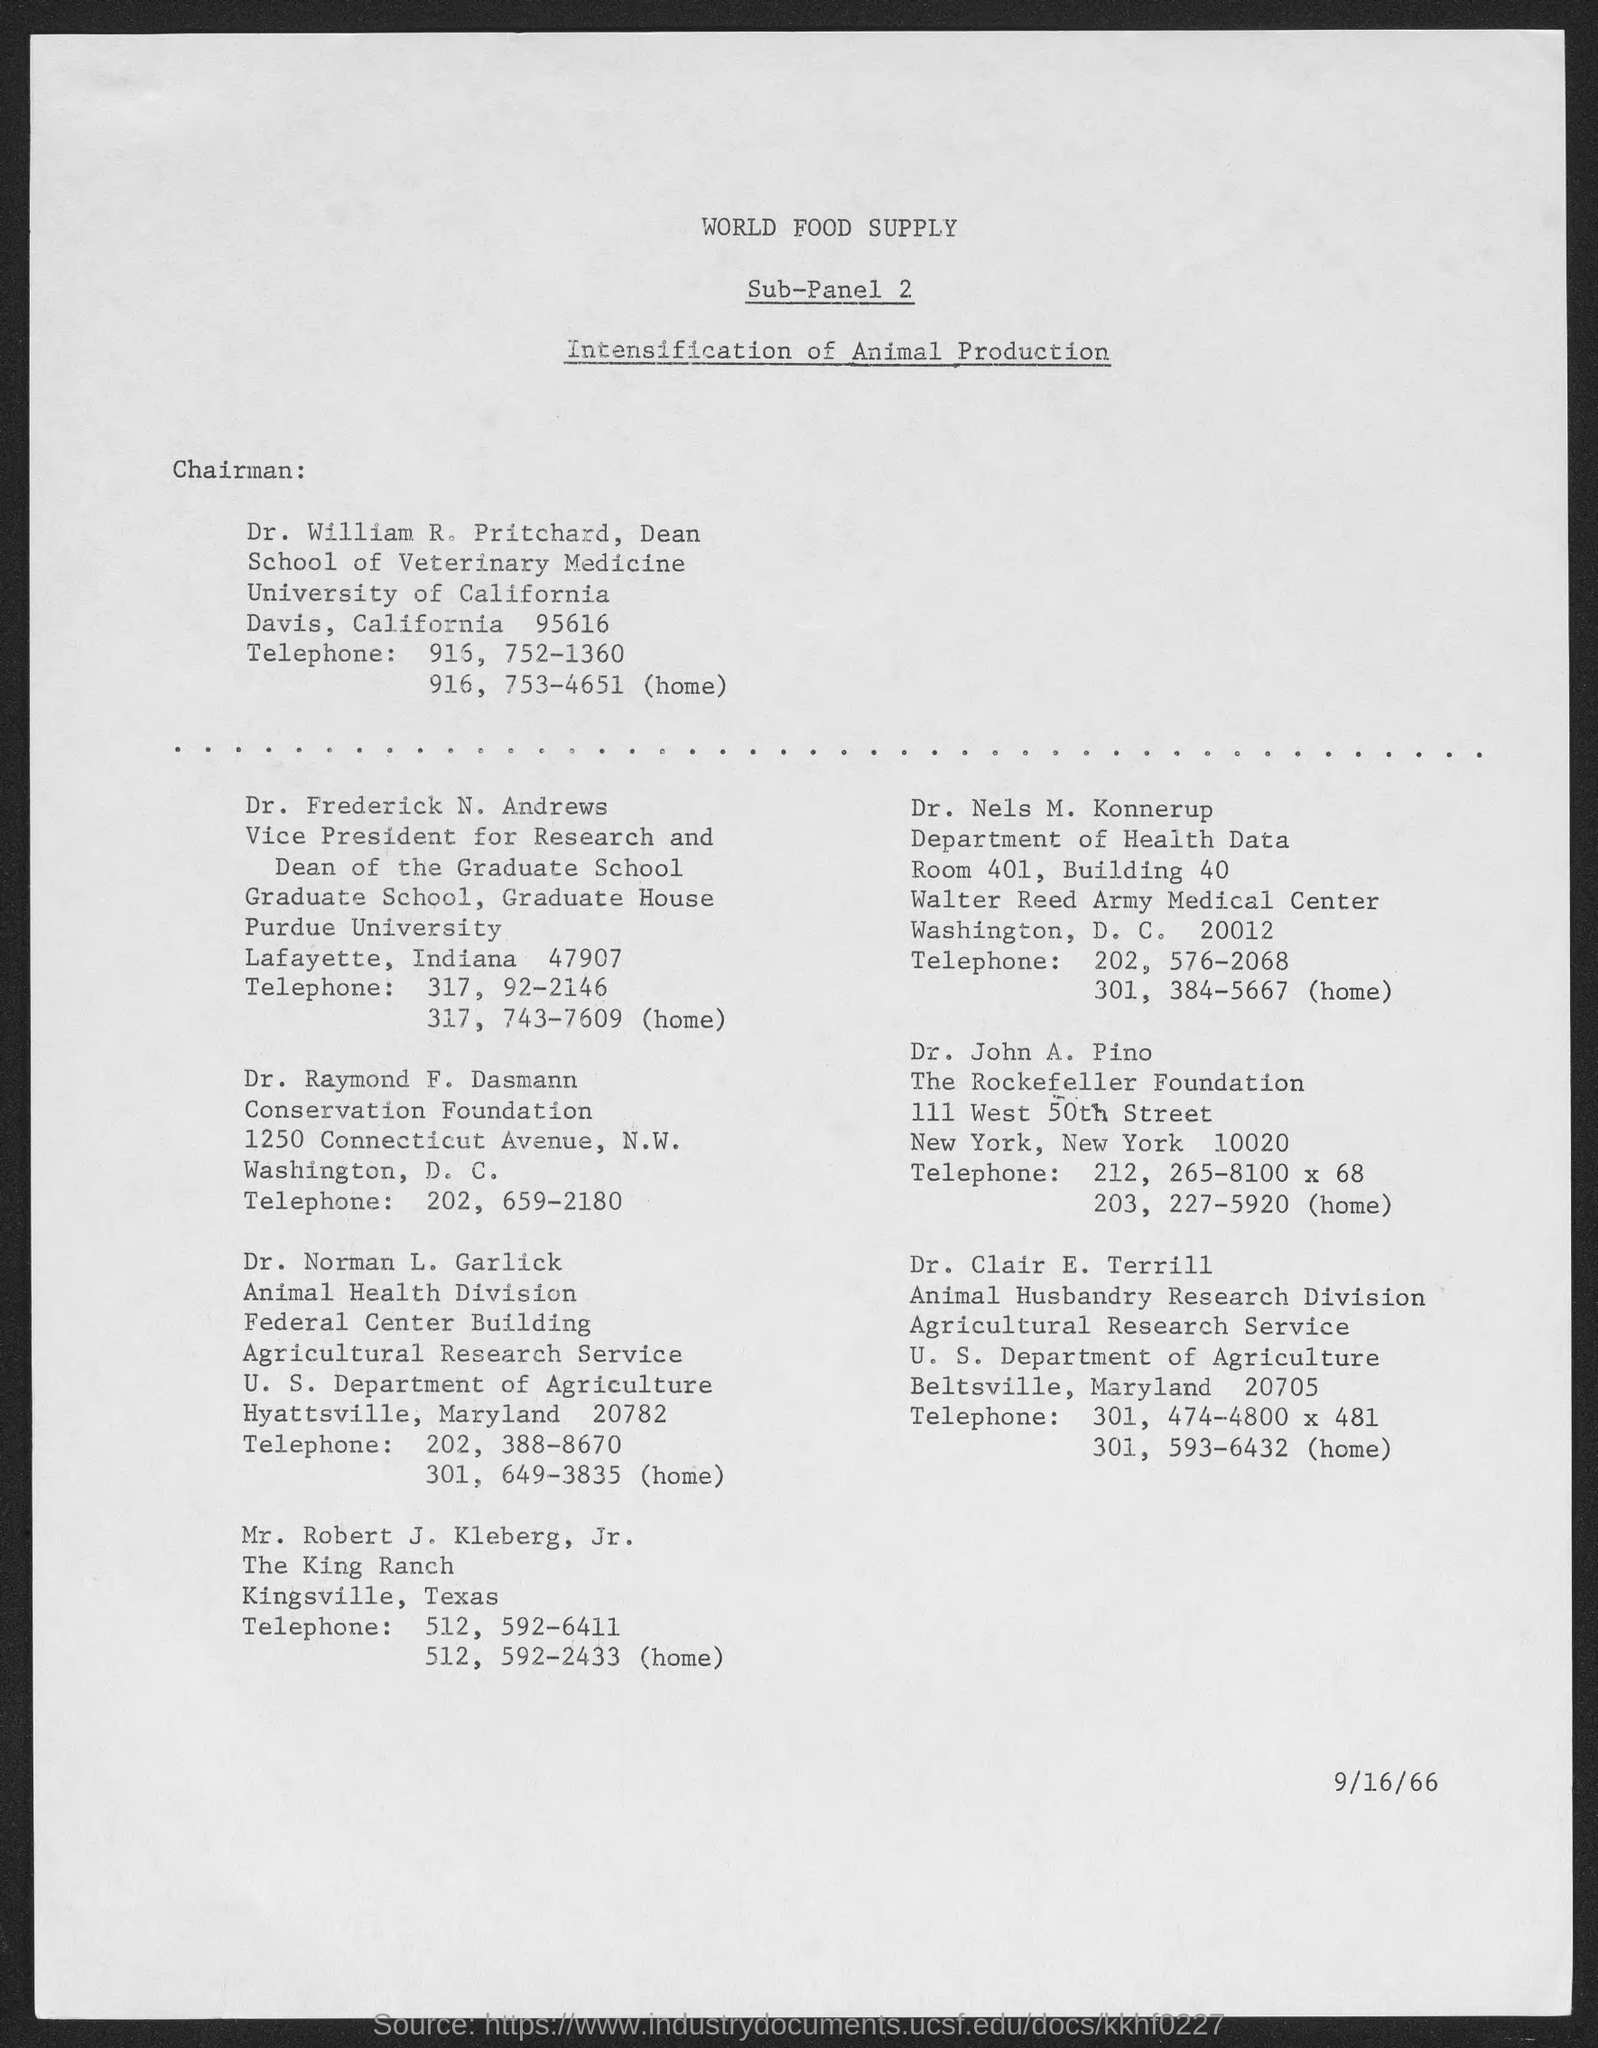To which university does dr. william r. pritchard belong?
Keep it short and to the point. University of california. What is the date at bottom of the page?
Offer a terse response. 9/16/66. 